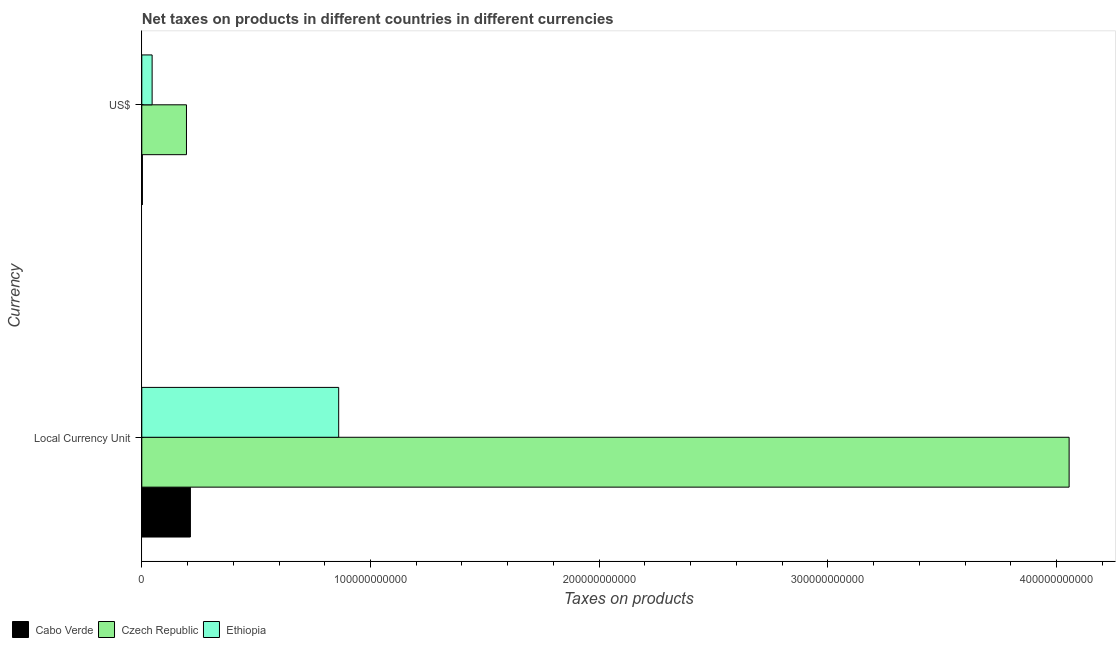How many groups of bars are there?
Provide a succinct answer. 2. Are the number of bars per tick equal to the number of legend labels?
Provide a succinct answer. Yes. How many bars are there on the 1st tick from the top?
Ensure brevity in your answer.  3. What is the label of the 1st group of bars from the top?
Offer a terse response. US$. What is the net taxes in us$ in Ethiopia?
Make the answer very short. 4.51e+09. Across all countries, what is the maximum net taxes in constant 2005 us$?
Offer a very short reply. 4.06e+11. Across all countries, what is the minimum net taxes in us$?
Offer a very short reply. 2.56e+08. In which country was the net taxes in us$ maximum?
Provide a succinct answer. Czech Republic. In which country was the net taxes in constant 2005 us$ minimum?
Keep it short and to the point. Cabo Verde. What is the total net taxes in us$ in the graph?
Make the answer very short. 2.43e+1. What is the difference between the net taxes in constant 2005 us$ in Cabo Verde and that in Czech Republic?
Ensure brevity in your answer.  -3.84e+11. What is the difference between the net taxes in us$ in Czech Republic and the net taxes in constant 2005 us$ in Cabo Verde?
Your answer should be very brief. -1.72e+09. What is the average net taxes in us$ per country?
Provide a succinct answer. 8.10e+09. What is the difference between the net taxes in constant 2005 us$ and net taxes in us$ in Cabo Verde?
Provide a short and direct response. 2.10e+1. In how many countries, is the net taxes in us$ greater than 180000000000 units?
Provide a succinct answer. 0. What is the ratio of the net taxes in us$ in Ethiopia to that in Cabo Verde?
Keep it short and to the point. 17.65. What does the 3rd bar from the top in US$ represents?
Keep it short and to the point. Cabo Verde. What does the 2nd bar from the bottom in US$ represents?
Keep it short and to the point. Czech Republic. How many bars are there?
Offer a very short reply. 6. What is the difference between two consecutive major ticks on the X-axis?
Give a very brief answer. 1.00e+11. Are the values on the major ticks of X-axis written in scientific E-notation?
Provide a short and direct response. No. Does the graph contain any zero values?
Offer a terse response. No. Does the graph contain grids?
Provide a succinct answer. No. What is the title of the graph?
Keep it short and to the point. Net taxes on products in different countries in different currencies. Does "Germany" appear as one of the legend labels in the graph?
Provide a succinct answer. No. What is the label or title of the X-axis?
Offer a terse response. Taxes on products. What is the label or title of the Y-axis?
Provide a short and direct response. Currency. What is the Taxes on products in Cabo Verde in Local Currency Unit?
Keep it short and to the point. 2.13e+1. What is the Taxes on products of Czech Republic in Local Currency Unit?
Your response must be concise. 4.06e+11. What is the Taxes on products in Ethiopia in Local Currency Unit?
Provide a short and direct response. 8.61e+1. What is the Taxes on products of Cabo Verde in US$?
Keep it short and to the point. 2.56e+08. What is the Taxes on products in Czech Republic in US$?
Give a very brief answer. 1.95e+1. What is the Taxes on products of Ethiopia in US$?
Ensure brevity in your answer.  4.51e+09. Across all Currency, what is the maximum Taxes on products of Cabo Verde?
Your answer should be compact. 2.13e+1. Across all Currency, what is the maximum Taxes on products in Czech Republic?
Provide a short and direct response. 4.06e+11. Across all Currency, what is the maximum Taxes on products in Ethiopia?
Offer a very short reply. 8.61e+1. Across all Currency, what is the minimum Taxes on products in Cabo Verde?
Your response must be concise. 2.56e+08. Across all Currency, what is the minimum Taxes on products in Czech Republic?
Make the answer very short. 1.95e+1. Across all Currency, what is the minimum Taxes on products of Ethiopia?
Provide a succinct answer. 4.51e+09. What is the total Taxes on products of Cabo Verde in the graph?
Give a very brief answer. 2.15e+1. What is the total Taxes on products of Czech Republic in the graph?
Your answer should be very brief. 4.25e+11. What is the total Taxes on products in Ethiopia in the graph?
Offer a very short reply. 9.06e+1. What is the difference between the Taxes on products in Cabo Verde in Local Currency Unit and that in US$?
Provide a short and direct response. 2.10e+1. What is the difference between the Taxes on products of Czech Republic in Local Currency Unit and that in US$?
Make the answer very short. 3.86e+11. What is the difference between the Taxes on products in Ethiopia in Local Currency Unit and that in US$?
Your answer should be compact. 8.16e+1. What is the difference between the Taxes on products of Cabo Verde in Local Currency Unit and the Taxes on products of Czech Republic in US$?
Your answer should be compact. 1.72e+09. What is the difference between the Taxes on products of Cabo Verde in Local Currency Unit and the Taxes on products of Ethiopia in US$?
Make the answer very short. 1.67e+1. What is the difference between the Taxes on products in Czech Republic in Local Currency Unit and the Taxes on products in Ethiopia in US$?
Your response must be concise. 4.01e+11. What is the average Taxes on products of Cabo Verde per Currency?
Offer a terse response. 1.08e+1. What is the average Taxes on products in Czech Republic per Currency?
Keep it short and to the point. 2.13e+11. What is the average Taxes on products in Ethiopia per Currency?
Your answer should be very brief. 4.53e+1. What is the difference between the Taxes on products in Cabo Verde and Taxes on products in Czech Republic in Local Currency Unit?
Offer a very short reply. -3.84e+11. What is the difference between the Taxes on products of Cabo Verde and Taxes on products of Ethiopia in Local Currency Unit?
Your response must be concise. -6.48e+1. What is the difference between the Taxes on products in Czech Republic and Taxes on products in Ethiopia in Local Currency Unit?
Make the answer very short. 3.19e+11. What is the difference between the Taxes on products of Cabo Verde and Taxes on products of Czech Republic in US$?
Offer a terse response. -1.93e+1. What is the difference between the Taxes on products in Cabo Verde and Taxes on products in Ethiopia in US$?
Your answer should be compact. -4.26e+09. What is the difference between the Taxes on products of Czech Republic and Taxes on products of Ethiopia in US$?
Make the answer very short. 1.50e+1. What is the ratio of the Taxes on products of Cabo Verde in Local Currency Unit to that in US$?
Make the answer very short. 83.11. What is the ratio of the Taxes on products of Czech Republic in Local Currency Unit to that in US$?
Your answer should be compact. 20.76. What is the ratio of the Taxes on products in Ethiopia in Local Currency Unit to that in US$?
Make the answer very short. 19.08. What is the difference between the highest and the second highest Taxes on products in Cabo Verde?
Keep it short and to the point. 2.10e+1. What is the difference between the highest and the second highest Taxes on products in Czech Republic?
Offer a terse response. 3.86e+11. What is the difference between the highest and the second highest Taxes on products of Ethiopia?
Provide a short and direct response. 8.16e+1. What is the difference between the highest and the lowest Taxes on products of Cabo Verde?
Offer a very short reply. 2.10e+1. What is the difference between the highest and the lowest Taxes on products in Czech Republic?
Provide a short and direct response. 3.86e+11. What is the difference between the highest and the lowest Taxes on products in Ethiopia?
Your answer should be compact. 8.16e+1. 